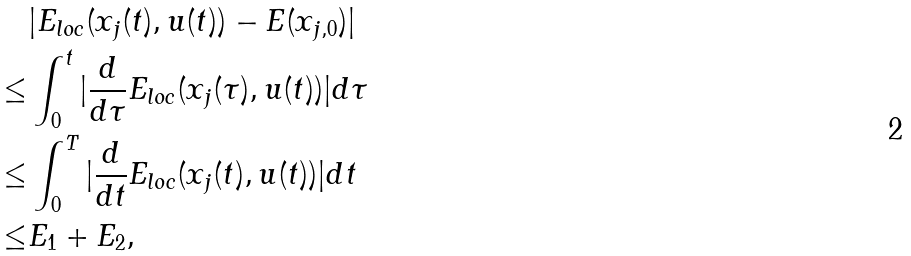<formula> <loc_0><loc_0><loc_500><loc_500>& | E _ { l o c } ( x _ { j } ( t ) , u ( t ) ) - E ( x _ { j , 0 } ) | \\ \leq & \int _ { 0 } ^ { t } | \frac { d } { d \tau } E _ { l o c } ( x _ { j } ( \tau ) , u ( t ) ) | d \tau \\ \leq & \int _ { 0 } ^ { T } | \frac { d } { d t } E _ { l o c } ( x _ { j } ( t ) , u ( t ) ) | d t \\ \leq & E _ { 1 } + E _ { 2 } ,</formula> 